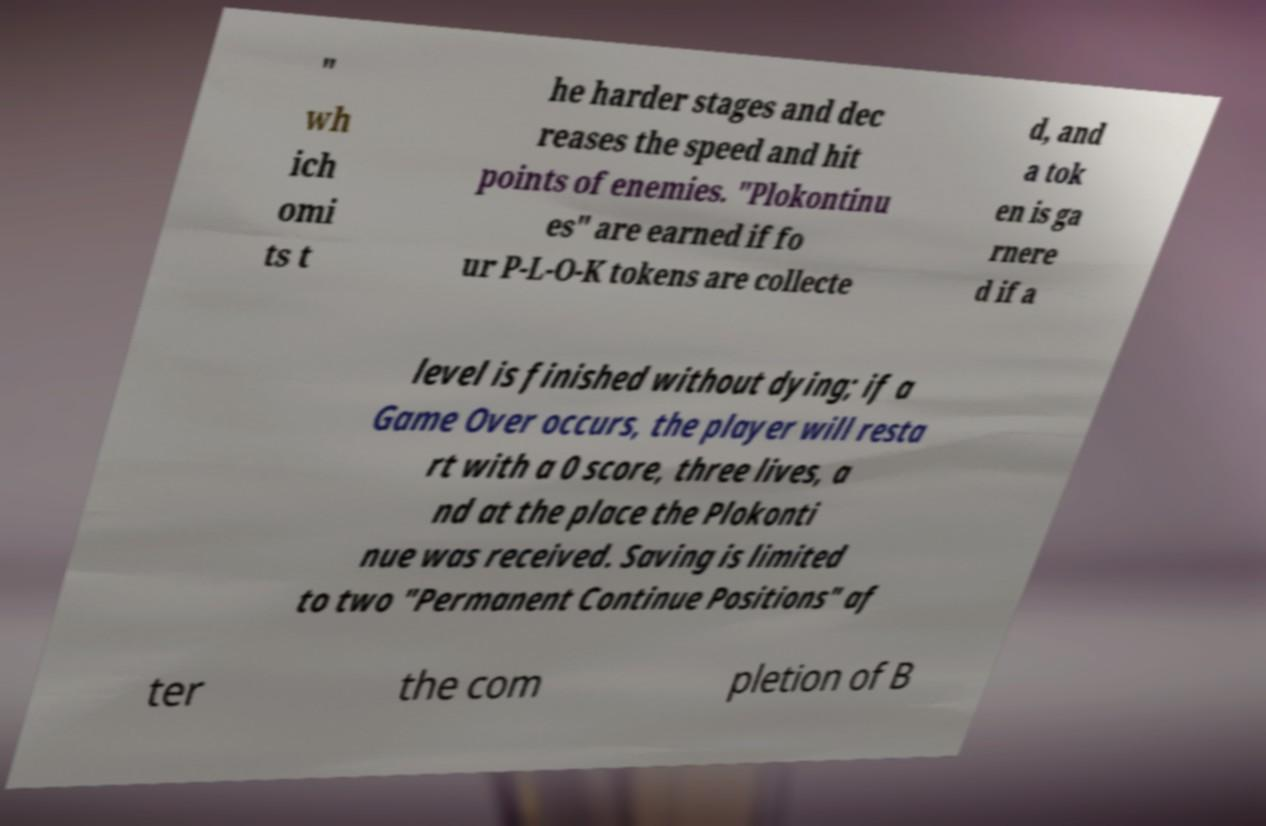What messages or text are displayed in this image? I need them in a readable, typed format. " wh ich omi ts t he harder stages and dec reases the speed and hit points of enemies. "Plokontinu es" are earned if fo ur P-L-O-K tokens are collecte d, and a tok en is ga rnere d if a level is finished without dying; if a Game Over occurs, the player will resta rt with a 0 score, three lives, a nd at the place the Plokonti nue was received. Saving is limited to two "Permanent Continue Positions" af ter the com pletion of B 